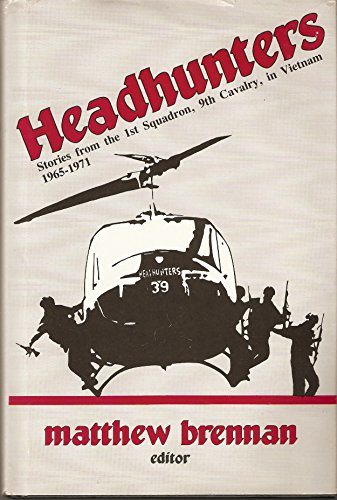What is the genre of this book? This book firmly fits into the genre of history, offering a detailed exploration of the events and personal experiences of the 1st Squadron in the Vietnam War during the years 1965 to 1971. 